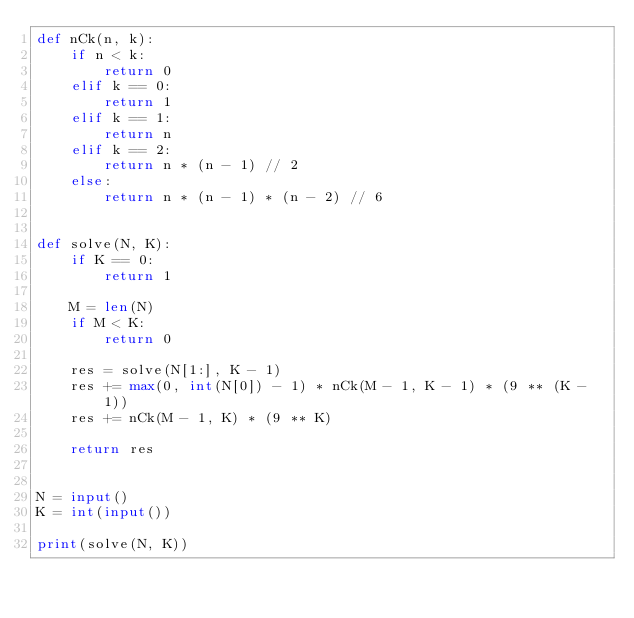Convert code to text. <code><loc_0><loc_0><loc_500><loc_500><_Python_>def nCk(n, k):
    if n < k:
        return 0
    elif k == 0:
        return 1
    elif k == 1:
        return n
    elif k == 2:
        return n * (n - 1) // 2
    else:
        return n * (n - 1) * (n - 2) // 6


def solve(N, K):
    if K == 0:
        return 1

    M = len(N)
    if M < K:
        return 0

    res = solve(N[1:], K - 1)
    res += max(0, int(N[0]) - 1) * nCk(M - 1, K - 1) * (9 ** (K - 1))
    res += nCk(M - 1, K) * (9 ** K)

    return res


N = input()
K = int(input())

print(solve(N, K))</code> 